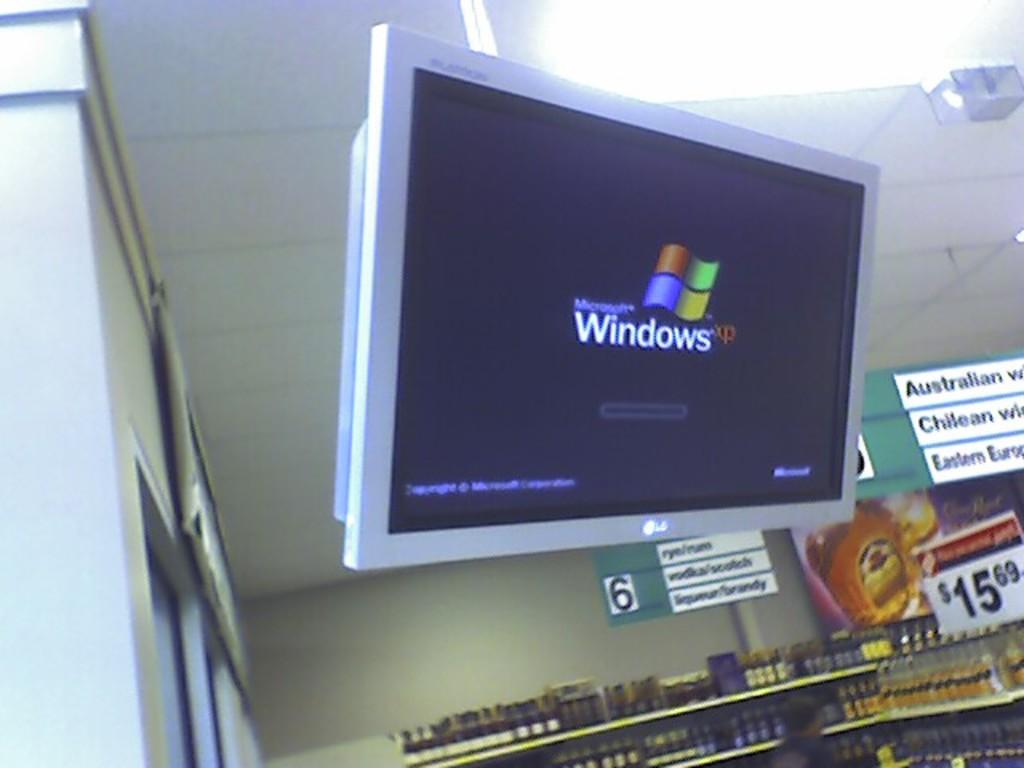What version of windows is it?
Ensure brevity in your answer.  Xp. What aisle includes vodka?
Offer a very short reply. 6. 